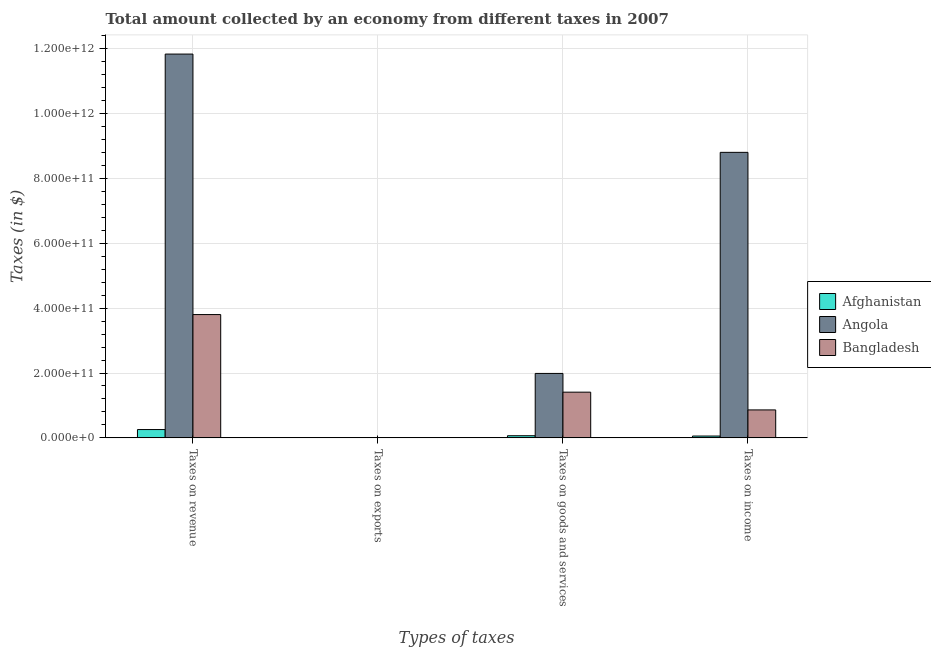How many different coloured bars are there?
Keep it short and to the point. 3. Are the number of bars per tick equal to the number of legend labels?
Provide a short and direct response. Yes. How many bars are there on the 4th tick from the left?
Your answer should be compact. 3. What is the label of the 1st group of bars from the left?
Provide a short and direct response. Taxes on revenue. What is the amount collected as tax on exports in Afghanistan?
Provide a succinct answer. 3.50e+06. Across all countries, what is the maximum amount collected as tax on revenue?
Make the answer very short. 1.18e+12. Across all countries, what is the minimum amount collected as tax on exports?
Make the answer very short. 3.38e+05. In which country was the amount collected as tax on goods maximum?
Provide a short and direct response. Angola. In which country was the amount collected as tax on goods minimum?
Ensure brevity in your answer.  Afghanistan. What is the total amount collected as tax on income in the graph?
Ensure brevity in your answer.  9.73e+11. What is the difference between the amount collected as tax on revenue in Bangladesh and that in Angola?
Your response must be concise. -8.04e+11. What is the difference between the amount collected as tax on exports in Bangladesh and the amount collected as tax on revenue in Angola?
Keep it short and to the point. -1.18e+12. What is the average amount collected as tax on exports per country?
Give a very brief answer. 2.50e+07. What is the difference between the amount collected as tax on income and amount collected as tax on goods in Bangladesh?
Your answer should be compact. -5.47e+1. In how many countries, is the amount collected as tax on revenue greater than 40000000000 $?
Ensure brevity in your answer.  2. What is the ratio of the amount collected as tax on revenue in Bangladesh to that in Angola?
Your answer should be very brief. 0.32. Is the amount collected as tax on revenue in Angola less than that in Afghanistan?
Provide a succinct answer. No. Is the difference between the amount collected as tax on goods in Angola and Afghanistan greater than the difference between the amount collected as tax on exports in Angola and Afghanistan?
Make the answer very short. Yes. What is the difference between the highest and the second highest amount collected as tax on income?
Your answer should be very brief. 7.95e+11. What is the difference between the highest and the lowest amount collected as tax on goods?
Your answer should be compact. 1.92e+11. In how many countries, is the amount collected as tax on exports greater than the average amount collected as tax on exports taken over all countries?
Offer a terse response. 1. Is it the case that in every country, the sum of the amount collected as tax on exports and amount collected as tax on revenue is greater than the sum of amount collected as tax on goods and amount collected as tax on income?
Your answer should be compact. Yes. What does the 1st bar from the left in Taxes on exports represents?
Your response must be concise. Afghanistan. What does the 3rd bar from the right in Taxes on income represents?
Keep it short and to the point. Afghanistan. Is it the case that in every country, the sum of the amount collected as tax on revenue and amount collected as tax on exports is greater than the amount collected as tax on goods?
Make the answer very short. Yes. How many bars are there?
Your response must be concise. 12. What is the difference between two consecutive major ticks on the Y-axis?
Provide a short and direct response. 2.00e+11. Are the values on the major ticks of Y-axis written in scientific E-notation?
Offer a terse response. Yes. Does the graph contain grids?
Your answer should be compact. Yes. What is the title of the graph?
Your answer should be compact. Total amount collected by an economy from different taxes in 2007. Does "Lithuania" appear as one of the legend labels in the graph?
Your answer should be compact. No. What is the label or title of the X-axis?
Keep it short and to the point. Types of taxes. What is the label or title of the Y-axis?
Make the answer very short. Taxes (in $). What is the Taxes (in $) in Afghanistan in Taxes on revenue?
Make the answer very short. 2.56e+1. What is the Taxes (in $) of Angola in Taxes on revenue?
Offer a terse response. 1.18e+12. What is the Taxes (in $) of Bangladesh in Taxes on revenue?
Keep it short and to the point. 3.80e+11. What is the Taxes (in $) in Afghanistan in Taxes on exports?
Your answer should be compact. 3.50e+06. What is the Taxes (in $) of Angola in Taxes on exports?
Offer a terse response. 7.12e+07. What is the Taxes (in $) of Bangladesh in Taxes on exports?
Keep it short and to the point. 3.38e+05. What is the Taxes (in $) in Afghanistan in Taxes on goods and services?
Ensure brevity in your answer.  6.62e+09. What is the Taxes (in $) of Angola in Taxes on goods and services?
Give a very brief answer. 1.99e+11. What is the Taxes (in $) of Bangladesh in Taxes on goods and services?
Give a very brief answer. 1.41e+11. What is the Taxes (in $) in Afghanistan in Taxes on income?
Ensure brevity in your answer.  5.64e+09. What is the Taxes (in $) in Angola in Taxes on income?
Ensure brevity in your answer.  8.81e+11. What is the Taxes (in $) of Bangladesh in Taxes on income?
Offer a very short reply. 8.62e+1. Across all Types of taxes, what is the maximum Taxes (in $) of Afghanistan?
Provide a short and direct response. 2.56e+1. Across all Types of taxes, what is the maximum Taxes (in $) of Angola?
Your response must be concise. 1.18e+12. Across all Types of taxes, what is the maximum Taxes (in $) of Bangladesh?
Your answer should be very brief. 3.80e+11. Across all Types of taxes, what is the minimum Taxes (in $) in Afghanistan?
Your answer should be compact. 3.50e+06. Across all Types of taxes, what is the minimum Taxes (in $) in Angola?
Your response must be concise. 7.12e+07. Across all Types of taxes, what is the minimum Taxes (in $) of Bangladesh?
Your response must be concise. 3.38e+05. What is the total Taxes (in $) in Afghanistan in the graph?
Your response must be concise. 3.79e+1. What is the total Taxes (in $) in Angola in the graph?
Your answer should be very brief. 2.26e+12. What is the total Taxes (in $) of Bangladesh in the graph?
Ensure brevity in your answer.  6.08e+11. What is the difference between the Taxes (in $) of Afghanistan in Taxes on revenue and that in Taxes on exports?
Make the answer very short. 2.56e+1. What is the difference between the Taxes (in $) of Angola in Taxes on revenue and that in Taxes on exports?
Your answer should be very brief. 1.18e+12. What is the difference between the Taxes (in $) in Bangladesh in Taxes on revenue and that in Taxes on exports?
Offer a terse response. 3.80e+11. What is the difference between the Taxes (in $) in Afghanistan in Taxes on revenue and that in Taxes on goods and services?
Provide a short and direct response. 1.90e+1. What is the difference between the Taxes (in $) of Angola in Taxes on revenue and that in Taxes on goods and services?
Your response must be concise. 9.85e+11. What is the difference between the Taxes (in $) of Bangladesh in Taxes on revenue and that in Taxes on goods and services?
Offer a terse response. 2.39e+11. What is the difference between the Taxes (in $) of Afghanistan in Taxes on revenue and that in Taxes on income?
Your response must be concise. 2.00e+1. What is the difference between the Taxes (in $) in Angola in Taxes on revenue and that in Taxes on income?
Keep it short and to the point. 3.03e+11. What is the difference between the Taxes (in $) in Bangladesh in Taxes on revenue and that in Taxes on income?
Keep it short and to the point. 2.94e+11. What is the difference between the Taxes (in $) in Afghanistan in Taxes on exports and that in Taxes on goods and services?
Keep it short and to the point. -6.62e+09. What is the difference between the Taxes (in $) of Angola in Taxes on exports and that in Taxes on goods and services?
Offer a terse response. -1.99e+11. What is the difference between the Taxes (in $) in Bangladesh in Taxes on exports and that in Taxes on goods and services?
Offer a terse response. -1.41e+11. What is the difference between the Taxes (in $) in Afghanistan in Taxes on exports and that in Taxes on income?
Your answer should be compact. -5.64e+09. What is the difference between the Taxes (in $) of Angola in Taxes on exports and that in Taxes on income?
Ensure brevity in your answer.  -8.81e+11. What is the difference between the Taxes (in $) of Bangladesh in Taxes on exports and that in Taxes on income?
Provide a short and direct response. -8.62e+1. What is the difference between the Taxes (in $) of Afghanistan in Taxes on goods and services and that in Taxes on income?
Give a very brief answer. 9.74e+08. What is the difference between the Taxes (in $) in Angola in Taxes on goods and services and that in Taxes on income?
Provide a short and direct response. -6.82e+11. What is the difference between the Taxes (in $) of Bangladesh in Taxes on goods and services and that in Taxes on income?
Your answer should be very brief. 5.47e+1. What is the difference between the Taxes (in $) of Afghanistan in Taxes on revenue and the Taxes (in $) of Angola in Taxes on exports?
Give a very brief answer. 2.56e+1. What is the difference between the Taxes (in $) in Afghanistan in Taxes on revenue and the Taxes (in $) in Bangladesh in Taxes on exports?
Your answer should be compact. 2.56e+1. What is the difference between the Taxes (in $) in Angola in Taxes on revenue and the Taxes (in $) in Bangladesh in Taxes on exports?
Make the answer very short. 1.18e+12. What is the difference between the Taxes (in $) of Afghanistan in Taxes on revenue and the Taxes (in $) of Angola in Taxes on goods and services?
Provide a succinct answer. -1.73e+11. What is the difference between the Taxes (in $) in Afghanistan in Taxes on revenue and the Taxes (in $) in Bangladesh in Taxes on goods and services?
Ensure brevity in your answer.  -1.15e+11. What is the difference between the Taxes (in $) in Angola in Taxes on revenue and the Taxes (in $) in Bangladesh in Taxes on goods and services?
Ensure brevity in your answer.  1.04e+12. What is the difference between the Taxes (in $) in Afghanistan in Taxes on revenue and the Taxes (in $) in Angola in Taxes on income?
Ensure brevity in your answer.  -8.55e+11. What is the difference between the Taxes (in $) in Afghanistan in Taxes on revenue and the Taxes (in $) in Bangladesh in Taxes on income?
Keep it short and to the point. -6.06e+1. What is the difference between the Taxes (in $) in Angola in Taxes on revenue and the Taxes (in $) in Bangladesh in Taxes on income?
Your response must be concise. 1.10e+12. What is the difference between the Taxes (in $) in Afghanistan in Taxes on exports and the Taxes (in $) in Angola in Taxes on goods and services?
Your answer should be very brief. -1.99e+11. What is the difference between the Taxes (in $) of Afghanistan in Taxes on exports and the Taxes (in $) of Bangladesh in Taxes on goods and services?
Your response must be concise. -1.41e+11. What is the difference between the Taxes (in $) in Angola in Taxes on exports and the Taxes (in $) in Bangladesh in Taxes on goods and services?
Your response must be concise. -1.41e+11. What is the difference between the Taxes (in $) of Afghanistan in Taxes on exports and the Taxes (in $) of Angola in Taxes on income?
Provide a short and direct response. -8.81e+11. What is the difference between the Taxes (in $) in Afghanistan in Taxes on exports and the Taxes (in $) in Bangladesh in Taxes on income?
Ensure brevity in your answer.  -8.62e+1. What is the difference between the Taxes (in $) of Angola in Taxes on exports and the Taxes (in $) of Bangladesh in Taxes on income?
Your response must be concise. -8.61e+1. What is the difference between the Taxes (in $) in Afghanistan in Taxes on goods and services and the Taxes (in $) in Angola in Taxes on income?
Ensure brevity in your answer.  -8.74e+11. What is the difference between the Taxes (in $) of Afghanistan in Taxes on goods and services and the Taxes (in $) of Bangladesh in Taxes on income?
Make the answer very short. -7.96e+1. What is the difference between the Taxes (in $) in Angola in Taxes on goods and services and the Taxes (in $) in Bangladesh in Taxes on income?
Provide a succinct answer. 1.13e+11. What is the average Taxes (in $) in Afghanistan per Types of taxes?
Your answer should be compact. 9.48e+09. What is the average Taxes (in $) of Angola per Types of taxes?
Provide a short and direct response. 5.66e+11. What is the average Taxes (in $) in Bangladesh per Types of taxes?
Your response must be concise. 1.52e+11. What is the difference between the Taxes (in $) of Afghanistan and Taxes (in $) of Angola in Taxes on revenue?
Your answer should be compact. -1.16e+12. What is the difference between the Taxes (in $) in Afghanistan and Taxes (in $) in Bangladesh in Taxes on revenue?
Offer a very short reply. -3.55e+11. What is the difference between the Taxes (in $) of Angola and Taxes (in $) of Bangladesh in Taxes on revenue?
Ensure brevity in your answer.  8.04e+11. What is the difference between the Taxes (in $) of Afghanistan and Taxes (in $) of Angola in Taxes on exports?
Provide a short and direct response. -6.76e+07. What is the difference between the Taxes (in $) in Afghanistan and Taxes (in $) in Bangladesh in Taxes on exports?
Keep it short and to the point. 3.17e+06. What is the difference between the Taxes (in $) of Angola and Taxes (in $) of Bangladesh in Taxes on exports?
Give a very brief answer. 7.08e+07. What is the difference between the Taxes (in $) of Afghanistan and Taxes (in $) of Angola in Taxes on goods and services?
Offer a very short reply. -1.92e+11. What is the difference between the Taxes (in $) in Afghanistan and Taxes (in $) in Bangladesh in Taxes on goods and services?
Keep it short and to the point. -1.34e+11. What is the difference between the Taxes (in $) of Angola and Taxes (in $) of Bangladesh in Taxes on goods and services?
Provide a succinct answer. 5.78e+1. What is the difference between the Taxes (in $) in Afghanistan and Taxes (in $) in Angola in Taxes on income?
Your response must be concise. -8.75e+11. What is the difference between the Taxes (in $) of Afghanistan and Taxes (in $) of Bangladesh in Taxes on income?
Offer a very short reply. -8.06e+1. What is the difference between the Taxes (in $) of Angola and Taxes (in $) of Bangladesh in Taxes on income?
Give a very brief answer. 7.95e+11. What is the ratio of the Taxes (in $) in Afghanistan in Taxes on revenue to that in Taxes on exports?
Offer a very short reply. 7318.01. What is the ratio of the Taxes (in $) of Angola in Taxes on revenue to that in Taxes on exports?
Your answer should be compact. 1.66e+04. What is the ratio of the Taxes (in $) in Bangladesh in Taxes on revenue to that in Taxes on exports?
Provide a short and direct response. 1.13e+06. What is the ratio of the Taxes (in $) of Afghanistan in Taxes on revenue to that in Taxes on goods and services?
Keep it short and to the point. 3.88. What is the ratio of the Taxes (in $) of Angola in Taxes on revenue to that in Taxes on goods and services?
Make the answer very short. 5.96. What is the ratio of the Taxes (in $) of Bangladesh in Taxes on revenue to that in Taxes on goods and services?
Keep it short and to the point. 2.7. What is the ratio of the Taxes (in $) in Afghanistan in Taxes on revenue to that in Taxes on income?
Give a very brief answer. 4.54. What is the ratio of the Taxes (in $) of Angola in Taxes on revenue to that in Taxes on income?
Give a very brief answer. 1.34. What is the ratio of the Taxes (in $) in Bangladesh in Taxes on revenue to that in Taxes on income?
Your answer should be very brief. 4.41. What is the ratio of the Taxes (in $) in Afghanistan in Taxes on exports to that in Taxes on goods and services?
Provide a succinct answer. 0. What is the ratio of the Taxes (in $) in Afghanistan in Taxes on exports to that in Taxes on income?
Give a very brief answer. 0. What is the ratio of the Taxes (in $) of Angola in Taxes on exports to that in Taxes on income?
Offer a very short reply. 0. What is the ratio of the Taxes (in $) of Bangladesh in Taxes on exports to that in Taxes on income?
Your answer should be compact. 0. What is the ratio of the Taxes (in $) of Afghanistan in Taxes on goods and services to that in Taxes on income?
Give a very brief answer. 1.17. What is the ratio of the Taxes (in $) of Angola in Taxes on goods and services to that in Taxes on income?
Make the answer very short. 0.23. What is the ratio of the Taxes (in $) of Bangladesh in Taxes on goods and services to that in Taxes on income?
Provide a succinct answer. 1.64. What is the difference between the highest and the second highest Taxes (in $) in Afghanistan?
Your answer should be compact. 1.90e+1. What is the difference between the highest and the second highest Taxes (in $) of Angola?
Your response must be concise. 3.03e+11. What is the difference between the highest and the second highest Taxes (in $) of Bangladesh?
Give a very brief answer. 2.39e+11. What is the difference between the highest and the lowest Taxes (in $) of Afghanistan?
Your answer should be compact. 2.56e+1. What is the difference between the highest and the lowest Taxes (in $) of Angola?
Your response must be concise. 1.18e+12. What is the difference between the highest and the lowest Taxes (in $) of Bangladesh?
Your answer should be compact. 3.80e+11. 